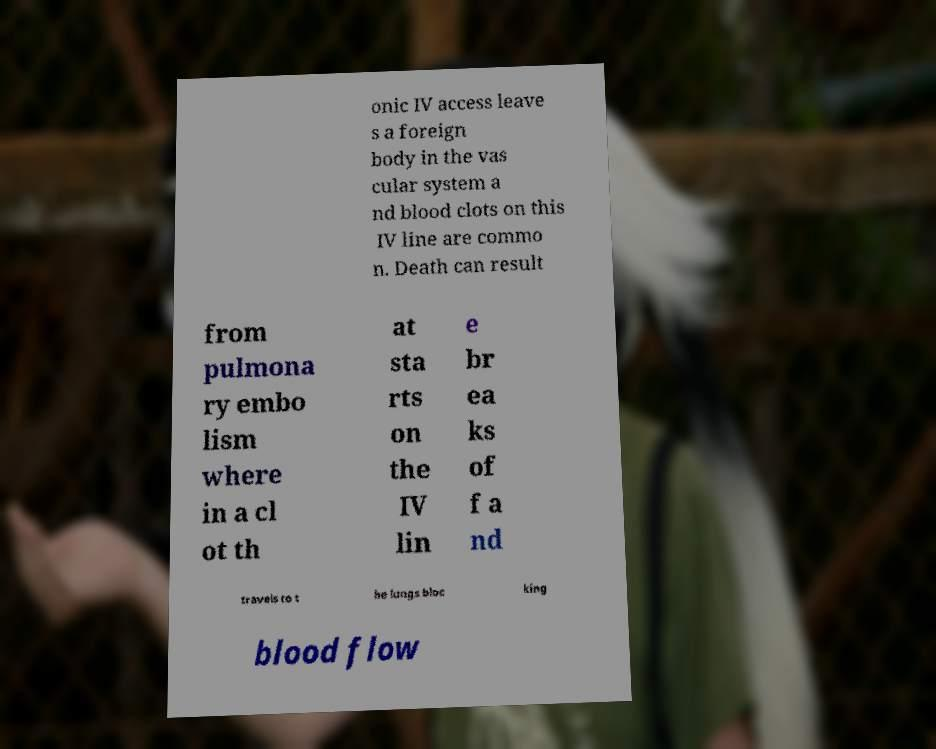I need the written content from this picture converted into text. Can you do that? onic IV access leave s a foreign body in the vas cular system a nd blood clots on this IV line are commo n. Death can result from pulmona ry embo lism where in a cl ot th at sta rts on the IV lin e br ea ks of f a nd travels to t he lungs bloc king blood flow 